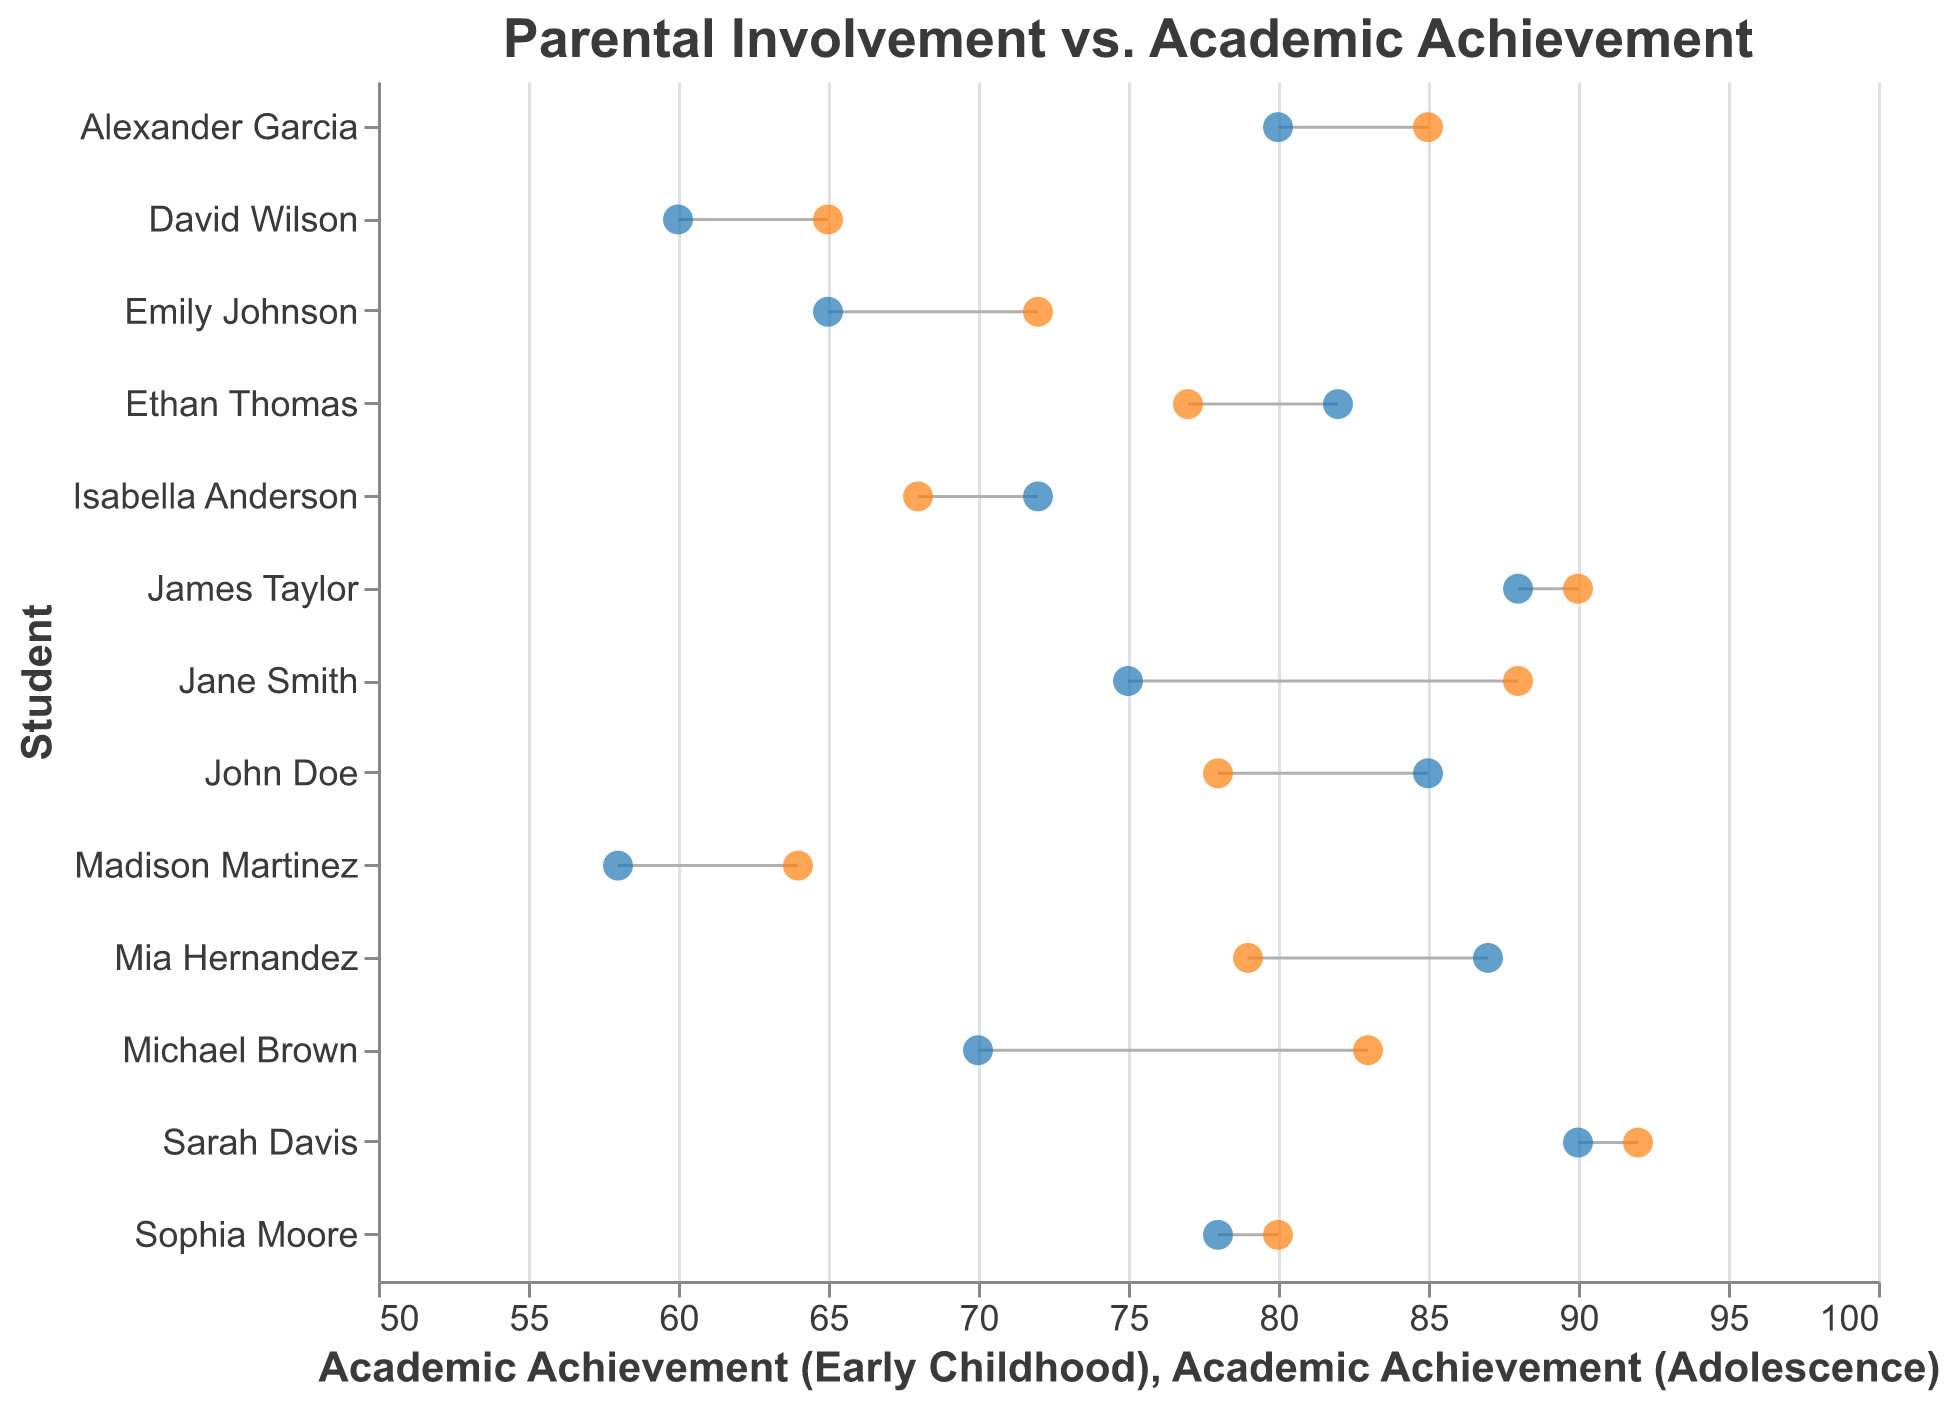What is the title of the figure? The title is located at the top of the figure and gives an overview of its content. In this case, the title is "Parental Involvement vs. Academic Achievement."
Answer: Parental Involvement vs. Academic Achievement How many individual data points are plotted for early childhood Academic Achievement? Each student has one data point for early childhood Academic Achievement. We can count the number of students listed on the y-axis. There are 13 students in total.
Answer: 13 Which student has the highest combined Academic Achievement score (early childhood plus adolescence)? To find the student with the highest combined score, we sum the early childhood and adolescence Academic Achievement for each student and compare them. The highest combined score is for Sarah Davis, with scores of 90 and 92, totaling 182.
Answer: Sarah Davis How many students showed a decrease in Academic Achievement from early childhood to adolescence? To determine this, compare the early childhood Academic Achievement and adolescence Academic Achievement for each student. Those with higher early childhood scores indicate a decrease. There are five students: John Doe, Ethan Thomas, Mia Hernandez, Isabella Anderson, and Emily Johnson.
Answer: 5 What is the most notable trend seen in the figure related to changes in Parental Involvement from early childhood to adolescence? Observing the data points, it is noticeable that students with initially high Parental Involvement often have it decrease over time, while those with low involvement show increases.
Answer: Decrease in initially high Parental Involvement Which students had the same level of Parental Involvement in both early childhood and adolescence? Cross-referencing students' Parental Involvement levels at both stages finds that Sarah Davis, David Wilson, Sophia Moore, and James Taylor had consistent levels across both phases.
Answer: Sarah Davis, David Wilson, Sophia Moore, James Taylor Compare the Academic Achievement of Michael Brown and Emily Johnson in adolescence. Who performed better? Look at the Academic Achievement (Adolescence) scores for both students: Michael Brown scores 83, whereas Emily Johnson scores 72. Michael Brown performed better.
Answer: Michael Brown What is the average Academic Achievement in adolescence for students who had medium Parental Involvement in early childhood? Identify students with medium Parental Involvement in early childhood, then calculate the average of their adolescence Academic Achievement scores. The students are Jane Smith (88), Michael Brown (83), Sophia Moore (80), Isabella Anderson (68), and Alexander Garcia (85), totaling 404. The average is 404/5 = 80.8.
Answer: 80.8 Which student exhibited the highest increase in Academic Achievement from early childhood to adolescence? Calculate the difference between adolescence and early childhood Academic Achievements for each student. Jane Smith had an increase from 75 to 88, a total increase of 13 points, the highest among all students.
Answer: Jane Smith 